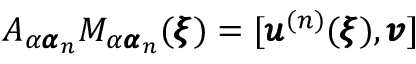<formula> <loc_0><loc_0><loc_500><loc_500>A _ { \alpha { \pm b \alpha } _ { n } } M _ { \alpha { \pm b \alpha } _ { n } } ( { \pm b \xi } ) = [ { \pm b u } ^ { ( n ) } ( { \pm b \xi } ) , { \pm b v } ]</formula> 